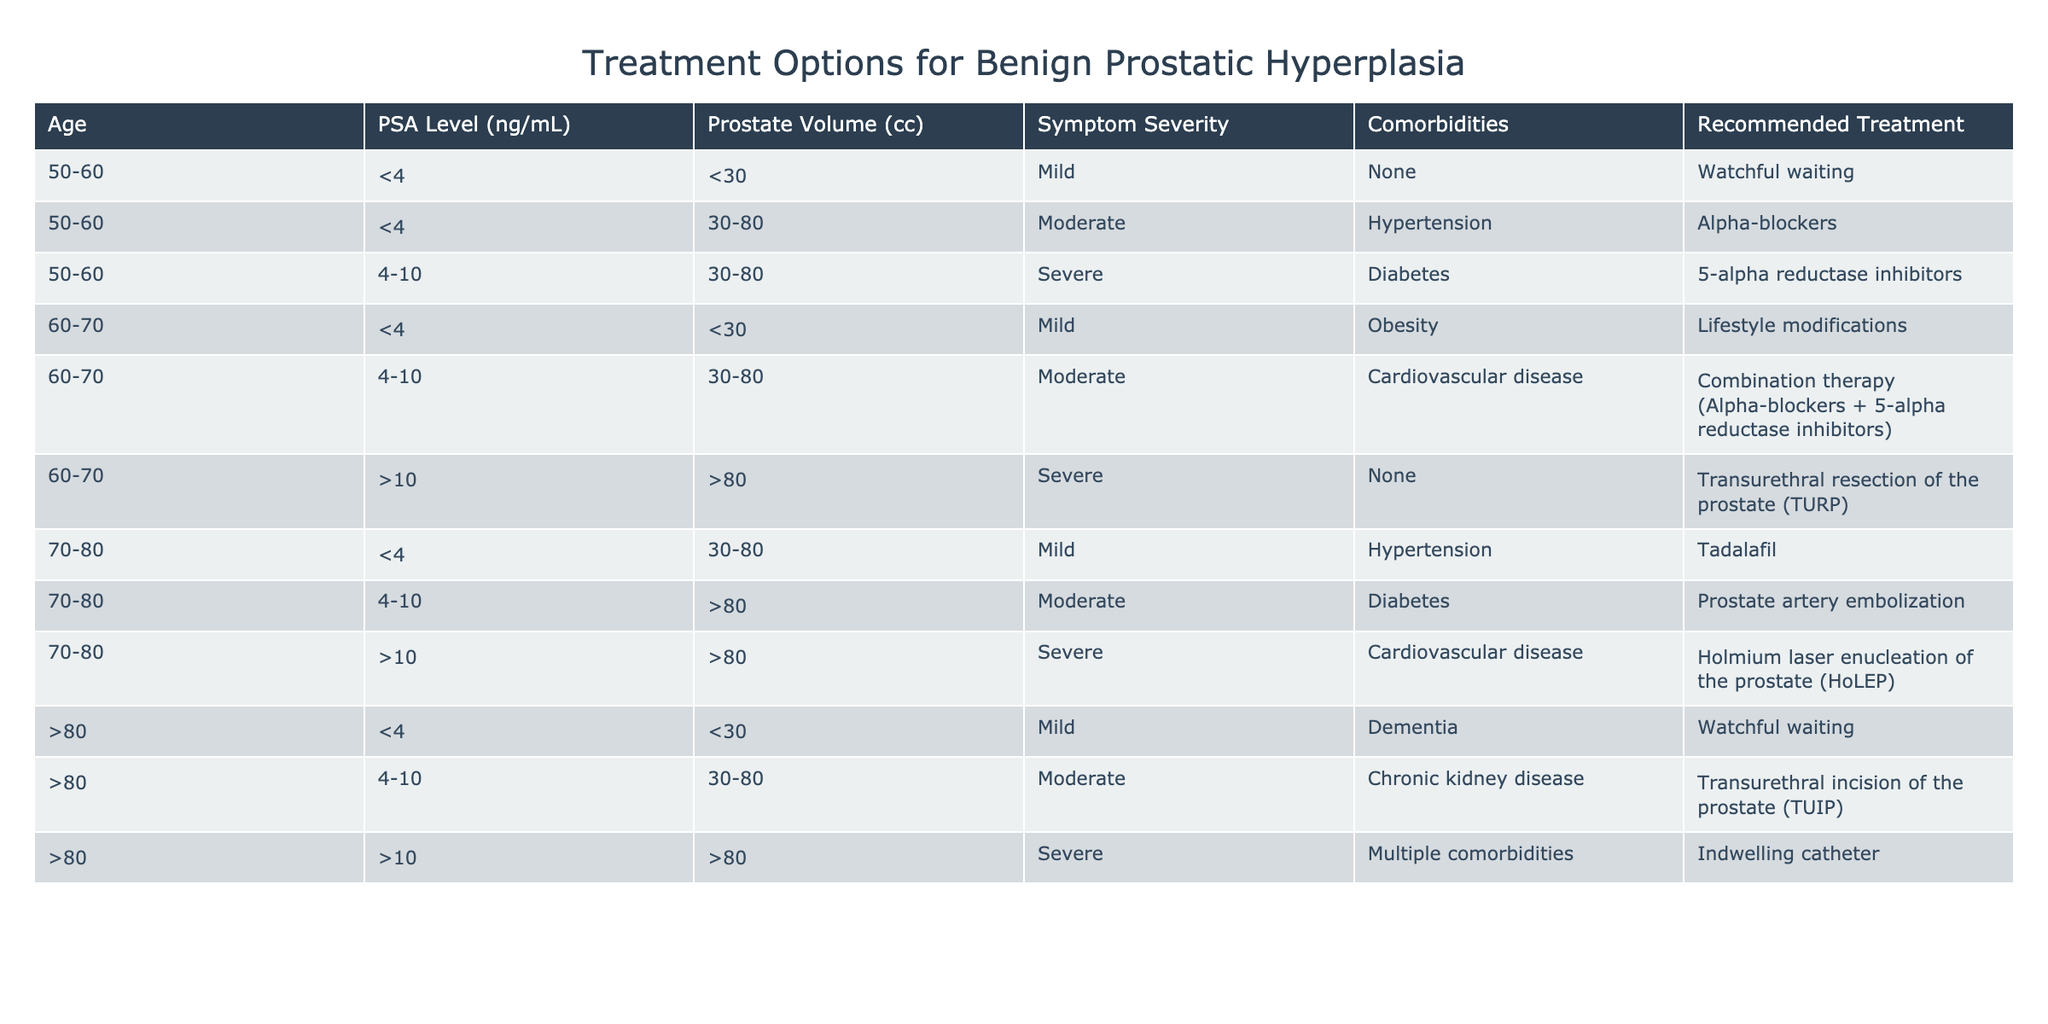What is the recommended treatment for a 65-year-old patient with a PSA level of 5 ng/mL? The patient is in the age group of 60-70, with a PSA level of 4-10 ng/mL. Based on the table, for this criteria and their symptom severity not specified, I would refer to the recommended treatment for moderate-severe cases, which is combination therapy (Alpha-blockers + 5-alpha reductase inhibitors). However, if we consider the moderate symptom severity it directly aligns, as the PSA level fits. Therefore, the answer is combination therapy.
Answer: Combination therapy (Alpha-blockers + 5-alpha reductase inhibitors) For a patient older than 80 with a PSA level greater than 10 ng/mL, which treatment is suggested? Based on the table, the only condition that matches is that a patient older than 80 with a PSA level of >10 falls under the severe symptom category and has multiple comorbidities. The recommended treatment in this case is the indwelling catheter.
Answer: Indwelling catheter Are 70-80-year-old patients with mild symptoms advised to have a treatment? From the table, patients aged 70-80 with mild symptoms receive the recommendation of Tadalafil. However, examining the recommendation shows that the treatment is based upon rather than outright treatment, watchful waiting may also be an option. Therefore, the correct answer to if they are advised to have treatment is Yes.
Answer: Yes What is the treatment for a 60-70-year-old with severe symptoms and a PSA level of 11 ng/mL? Looking at the table again, the patient falls into 60-70 age group and matches severe symptoms. The criteria mentions that if there is a PSA level over 10 with prostate volume over 80, then Transurethral resection of the prostate (TURP) is recommended. Hence, that’s the only fitting option.
Answer: Transurethral resection of the prostate (TURP) How many different treatments are recommended for patients aged 50-60? In the age group of 50-60, there are three distinct treatments listed: Watchful waiting, Alpha-blockers for moderate cases, and 5-alpha reductase inhibitors for severe cases. Summing these provides us with the answer.
Answer: 3 What treatment is suggested if there is a patient aged 70-80 with moderate symptoms but no comorbidities? The table indicates that for patients aged 70-80 years with moderate symptoms, the absence of comorbidities guides us to look for the specific treatment recommended for their age and symptoms. In this instance, they would require prostate artery embolization for the moderate case, thus they will be treated accordingly.
Answer: Prostate artery embolization 